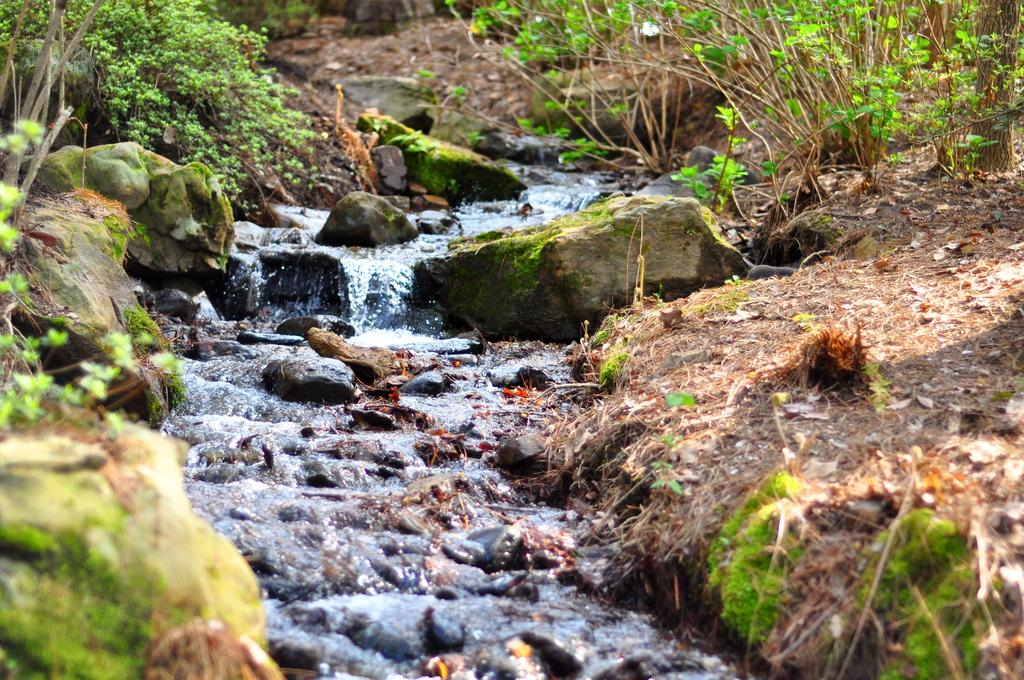What is the main feature of the image? The main feature of the image is water flowing in the middle of the picture. What can be found within the water? There are stones in the water. What type of vegetation is present in the image? There are plants on the ground. What type of calculator can be seen floating in the water? There is no calculator present in the image; it features water flowing with stones and plants on the ground. 